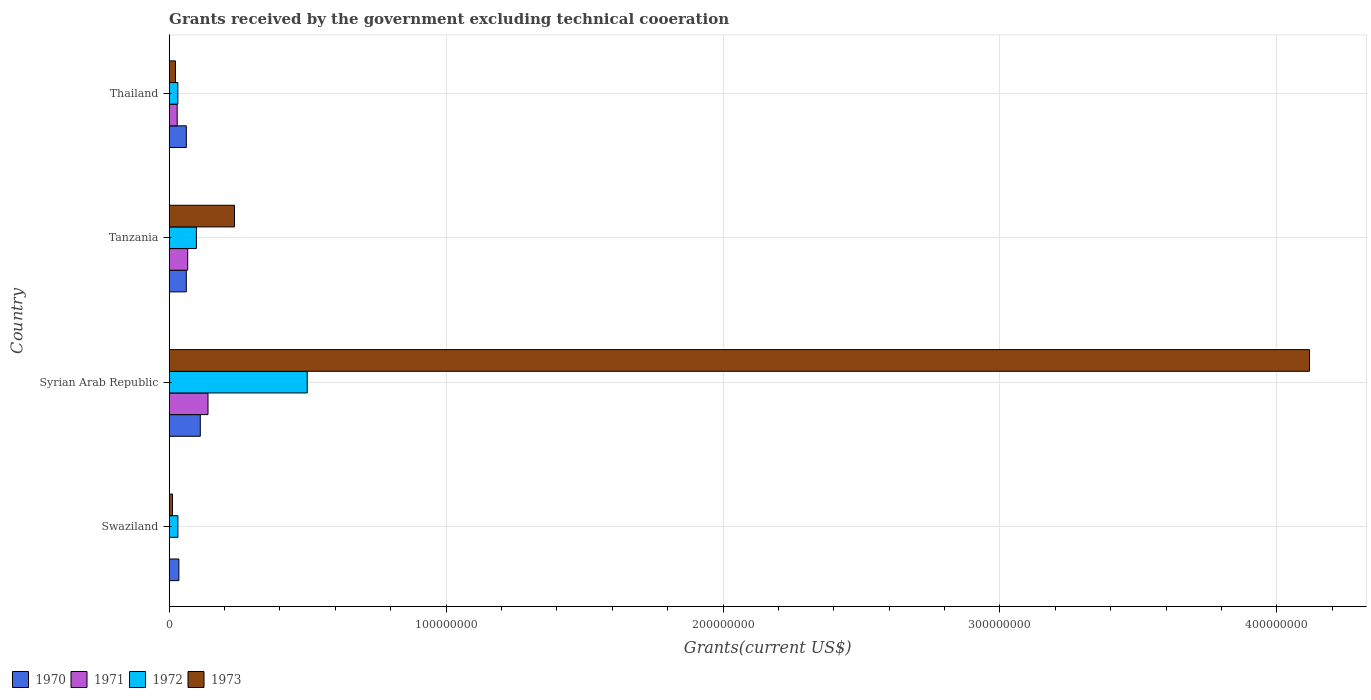How many groups of bars are there?
Ensure brevity in your answer.  4. Are the number of bars per tick equal to the number of legend labels?
Your answer should be compact. No. Are the number of bars on each tick of the Y-axis equal?
Offer a terse response. No. How many bars are there on the 2nd tick from the bottom?
Ensure brevity in your answer.  4. What is the label of the 3rd group of bars from the top?
Provide a succinct answer. Syrian Arab Republic. In how many cases, is the number of bars for a given country not equal to the number of legend labels?
Your response must be concise. 1. What is the total grants received by the government in 1971 in Syrian Arab Republic?
Offer a terse response. 1.40e+07. Across all countries, what is the maximum total grants received by the government in 1972?
Make the answer very short. 4.98e+07. Across all countries, what is the minimum total grants received by the government in 1970?
Ensure brevity in your answer.  3.49e+06. In which country was the total grants received by the government in 1972 maximum?
Keep it short and to the point. Syrian Arab Republic. What is the total total grants received by the government in 1970 in the graph?
Ensure brevity in your answer.  2.71e+07. What is the difference between the total grants received by the government in 1972 in Tanzania and that in Thailand?
Ensure brevity in your answer.  6.70e+06. What is the difference between the total grants received by the government in 1972 in Tanzania and the total grants received by the government in 1971 in Swaziland?
Ensure brevity in your answer.  9.82e+06. What is the average total grants received by the government in 1970 per country?
Provide a short and direct response. 6.77e+06. What is the difference between the total grants received by the government in 1972 and total grants received by the government in 1971 in Tanzania?
Offer a terse response. 3.14e+06. In how many countries, is the total grants received by the government in 1971 greater than 80000000 US$?
Your response must be concise. 0. What is the ratio of the total grants received by the government in 1972 in Swaziland to that in Syrian Arab Republic?
Your answer should be very brief. 0.06. What is the difference between the highest and the second highest total grants received by the government in 1970?
Your answer should be compact. 5.05e+06. What is the difference between the highest and the lowest total grants received by the government in 1972?
Provide a succinct answer. 4.67e+07. Is it the case that in every country, the sum of the total grants received by the government in 1973 and total grants received by the government in 1971 is greater than the total grants received by the government in 1972?
Give a very brief answer. No. What is the difference between two consecutive major ticks on the X-axis?
Offer a very short reply. 1.00e+08. Does the graph contain grids?
Your answer should be compact. Yes. How many legend labels are there?
Keep it short and to the point. 4. How are the legend labels stacked?
Make the answer very short. Horizontal. What is the title of the graph?
Your answer should be compact. Grants received by the government excluding technical cooeration. Does "2001" appear as one of the legend labels in the graph?
Offer a very short reply. No. What is the label or title of the X-axis?
Give a very brief answer. Grants(current US$). What is the Grants(current US$) in 1970 in Swaziland?
Your answer should be compact. 3.49e+06. What is the Grants(current US$) in 1971 in Swaziland?
Your response must be concise. 0. What is the Grants(current US$) of 1972 in Swaziland?
Offer a terse response. 3.14e+06. What is the Grants(current US$) of 1973 in Swaziland?
Your response must be concise. 1.18e+06. What is the Grants(current US$) in 1970 in Syrian Arab Republic?
Your answer should be very brief. 1.12e+07. What is the Grants(current US$) in 1971 in Syrian Arab Republic?
Your answer should be very brief. 1.40e+07. What is the Grants(current US$) in 1972 in Syrian Arab Republic?
Offer a very short reply. 4.98e+07. What is the Grants(current US$) of 1973 in Syrian Arab Republic?
Keep it short and to the point. 4.12e+08. What is the Grants(current US$) in 1970 in Tanzania?
Provide a short and direct response. 6.17e+06. What is the Grants(current US$) in 1971 in Tanzania?
Provide a succinct answer. 6.68e+06. What is the Grants(current US$) in 1972 in Tanzania?
Offer a terse response. 9.82e+06. What is the Grants(current US$) of 1973 in Tanzania?
Your answer should be very brief. 2.36e+07. What is the Grants(current US$) of 1970 in Thailand?
Your answer should be compact. 6.18e+06. What is the Grants(current US$) in 1971 in Thailand?
Provide a succinct answer. 2.88e+06. What is the Grants(current US$) of 1972 in Thailand?
Provide a succinct answer. 3.12e+06. What is the Grants(current US$) of 1973 in Thailand?
Your response must be concise. 2.27e+06. Across all countries, what is the maximum Grants(current US$) of 1970?
Keep it short and to the point. 1.12e+07. Across all countries, what is the maximum Grants(current US$) in 1971?
Provide a short and direct response. 1.40e+07. Across all countries, what is the maximum Grants(current US$) of 1972?
Make the answer very short. 4.98e+07. Across all countries, what is the maximum Grants(current US$) of 1973?
Your answer should be very brief. 4.12e+08. Across all countries, what is the minimum Grants(current US$) of 1970?
Offer a terse response. 3.49e+06. Across all countries, what is the minimum Grants(current US$) of 1972?
Your response must be concise. 3.12e+06. Across all countries, what is the minimum Grants(current US$) of 1973?
Give a very brief answer. 1.18e+06. What is the total Grants(current US$) of 1970 in the graph?
Provide a succinct answer. 2.71e+07. What is the total Grants(current US$) of 1971 in the graph?
Your response must be concise. 2.36e+07. What is the total Grants(current US$) of 1972 in the graph?
Keep it short and to the point. 6.59e+07. What is the total Grants(current US$) in 1973 in the graph?
Make the answer very short. 4.39e+08. What is the difference between the Grants(current US$) in 1970 in Swaziland and that in Syrian Arab Republic?
Make the answer very short. -7.74e+06. What is the difference between the Grants(current US$) of 1972 in Swaziland and that in Syrian Arab Republic?
Provide a short and direct response. -4.67e+07. What is the difference between the Grants(current US$) in 1973 in Swaziland and that in Syrian Arab Republic?
Offer a very short reply. -4.11e+08. What is the difference between the Grants(current US$) in 1970 in Swaziland and that in Tanzania?
Give a very brief answer. -2.68e+06. What is the difference between the Grants(current US$) in 1972 in Swaziland and that in Tanzania?
Your response must be concise. -6.68e+06. What is the difference between the Grants(current US$) in 1973 in Swaziland and that in Tanzania?
Give a very brief answer. -2.24e+07. What is the difference between the Grants(current US$) in 1970 in Swaziland and that in Thailand?
Make the answer very short. -2.69e+06. What is the difference between the Grants(current US$) in 1972 in Swaziland and that in Thailand?
Provide a short and direct response. 2.00e+04. What is the difference between the Grants(current US$) of 1973 in Swaziland and that in Thailand?
Offer a terse response. -1.09e+06. What is the difference between the Grants(current US$) in 1970 in Syrian Arab Republic and that in Tanzania?
Give a very brief answer. 5.06e+06. What is the difference between the Grants(current US$) in 1971 in Syrian Arab Republic and that in Tanzania?
Your response must be concise. 7.33e+06. What is the difference between the Grants(current US$) of 1972 in Syrian Arab Republic and that in Tanzania?
Offer a terse response. 4.00e+07. What is the difference between the Grants(current US$) of 1973 in Syrian Arab Republic and that in Tanzania?
Give a very brief answer. 3.88e+08. What is the difference between the Grants(current US$) of 1970 in Syrian Arab Republic and that in Thailand?
Make the answer very short. 5.05e+06. What is the difference between the Grants(current US$) in 1971 in Syrian Arab Republic and that in Thailand?
Offer a terse response. 1.11e+07. What is the difference between the Grants(current US$) of 1972 in Syrian Arab Republic and that in Thailand?
Your response must be concise. 4.67e+07. What is the difference between the Grants(current US$) in 1973 in Syrian Arab Republic and that in Thailand?
Provide a succinct answer. 4.10e+08. What is the difference between the Grants(current US$) of 1971 in Tanzania and that in Thailand?
Your response must be concise. 3.80e+06. What is the difference between the Grants(current US$) of 1972 in Tanzania and that in Thailand?
Ensure brevity in your answer.  6.70e+06. What is the difference between the Grants(current US$) of 1973 in Tanzania and that in Thailand?
Offer a very short reply. 2.13e+07. What is the difference between the Grants(current US$) of 1970 in Swaziland and the Grants(current US$) of 1971 in Syrian Arab Republic?
Provide a short and direct response. -1.05e+07. What is the difference between the Grants(current US$) in 1970 in Swaziland and the Grants(current US$) in 1972 in Syrian Arab Republic?
Give a very brief answer. -4.64e+07. What is the difference between the Grants(current US$) of 1970 in Swaziland and the Grants(current US$) of 1973 in Syrian Arab Republic?
Make the answer very short. -4.08e+08. What is the difference between the Grants(current US$) of 1972 in Swaziland and the Grants(current US$) of 1973 in Syrian Arab Republic?
Offer a very short reply. -4.09e+08. What is the difference between the Grants(current US$) of 1970 in Swaziland and the Grants(current US$) of 1971 in Tanzania?
Give a very brief answer. -3.19e+06. What is the difference between the Grants(current US$) of 1970 in Swaziland and the Grants(current US$) of 1972 in Tanzania?
Your answer should be compact. -6.33e+06. What is the difference between the Grants(current US$) in 1970 in Swaziland and the Grants(current US$) in 1973 in Tanzania?
Offer a very short reply. -2.01e+07. What is the difference between the Grants(current US$) in 1972 in Swaziland and the Grants(current US$) in 1973 in Tanzania?
Give a very brief answer. -2.04e+07. What is the difference between the Grants(current US$) in 1970 in Swaziland and the Grants(current US$) in 1971 in Thailand?
Your response must be concise. 6.10e+05. What is the difference between the Grants(current US$) in 1970 in Swaziland and the Grants(current US$) in 1972 in Thailand?
Ensure brevity in your answer.  3.70e+05. What is the difference between the Grants(current US$) of 1970 in Swaziland and the Grants(current US$) of 1973 in Thailand?
Offer a very short reply. 1.22e+06. What is the difference between the Grants(current US$) of 1972 in Swaziland and the Grants(current US$) of 1973 in Thailand?
Ensure brevity in your answer.  8.70e+05. What is the difference between the Grants(current US$) of 1970 in Syrian Arab Republic and the Grants(current US$) of 1971 in Tanzania?
Make the answer very short. 4.55e+06. What is the difference between the Grants(current US$) in 1970 in Syrian Arab Republic and the Grants(current US$) in 1972 in Tanzania?
Provide a short and direct response. 1.41e+06. What is the difference between the Grants(current US$) of 1970 in Syrian Arab Republic and the Grants(current US$) of 1973 in Tanzania?
Your answer should be compact. -1.24e+07. What is the difference between the Grants(current US$) in 1971 in Syrian Arab Republic and the Grants(current US$) in 1972 in Tanzania?
Provide a succinct answer. 4.19e+06. What is the difference between the Grants(current US$) of 1971 in Syrian Arab Republic and the Grants(current US$) of 1973 in Tanzania?
Ensure brevity in your answer.  -9.57e+06. What is the difference between the Grants(current US$) of 1972 in Syrian Arab Republic and the Grants(current US$) of 1973 in Tanzania?
Make the answer very short. 2.63e+07. What is the difference between the Grants(current US$) in 1970 in Syrian Arab Republic and the Grants(current US$) in 1971 in Thailand?
Your answer should be compact. 8.35e+06. What is the difference between the Grants(current US$) of 1970 in Syrian Arab Republic and the Grants(current US$) of 1972 in Thailand?
Offer a terse response. 8.11e+06. What is the difference between the Grants(current US$) in 1970 in Syrian Arab Republic and the Grants(current US$) in 1973 in Thailand?
Your answer should be very brief. 8.96e+06. What is the difference between the Grants(current US$) in 1971 in Syrian Arab Republic and the Grants(current US$) in 1972 in Thailand?
Your answer should be compact. 1.09e+07. What is the difference between the Grants(current US$) in 1971 in Syrian Arab Republic and the Grants(current US$) in 1973 in Thailand?
Make the answer very short. 1.17e+07. What is the difference between the Grants(current US$) in 1972 in Syrian Arab Republic and the Grants(current US$) in 1973 in Thailand?
Give a very brief answer. 4.76e+07. What is the difference between the Grants(current US$) of 1970 in Tanzania and the Grants(current US$) of 1971 in Thailand?
Your answer should be very brief. 3.29e+06. What is the difference between the Grants(current US$) of 1970 in Tanzania and the Grants(current US$) of 1972 in Thailand?
Give a very brief answer. 3.05e+06. What is the difference between the Grants(current US$) of 1970 in Tanzania and the Grants(current US$) of 1973 in Thailand?
Keep it short and to the point. 3.90e+06. What is the difference between the Grants(current US$) in 1971 in Tanzania and the Grants(current US$) in 1972 in Thailand?
Offer a very short reply. 3.56e+06. What is the difference between the Grants(current US$) of 1971 in Tanzania and the Grants(current US$) of 1973 in Thailand?
Your answer should be compact. 4.41e+06. What is the difference between the Grants(current US$) of 1972 in Tanzania and the Grants(current US$) of 1973 in Thailand?
Make the answer very short. 7.55e+06. What is the average Grants(current US$) of 1970 per country?
Offer a terse response. 6.77e+06. What is the average Grants(current US$) of 1971 per country?
Make the answer very short. 5.89e+06. What is the average Grants(current US$) of 1972 per country?
Provide a short and direct response. 1.65e+07. What is the average Grants(current US$) of 1973 per country?
Your response must be concise. 1.10e+08. What is the difference between the Grants(current US$) of 1970 and Grants(current US$) of 1972 in Swaziland?
Your answer should be very brief. 3.50e+05. What is the difference between the Grants(current US$) in 1970 and Grants(current US$) in 1973 in Swaziland?
Give a very brief answer. 2.31e+06. What is the difference between the Grants(current US$) of 1972 and Grants(current US$) of 1973 in Swaziland?
Your response must be concise. 1.96e+06. What is the difference between the Grants(current US$) in 1970 and Grants(current US$) in 1971 in Syrian Arab Republic?
Keep it short and to the point. -2.78e+06. What is the difference between the Grants(current US$) of 1970 and Grants(current US$) of 1972 in Syrian Arab Republic?
Keep it short and to the point. -3.86e+07. What is the difference between the Grants(current US$) of 1970 and Grants(current US$) of 1973 in Syrian Arab Republic?
Provide a succinct answer. -4.01e+08. What is the difference between the Grants(current US$) of 1971 and Grants(current US$) of 1972 in Syrian Arab Republic?
Provide a succinct answer. -3.58e+07. What is the difference between the Grants(current US$) of 1971 and Grants(current US$) of 1973 in Syrian Arab Republic?
Offer a terse response. -3.98e+08. What is the difference between the Grants(current US$) in 1972 and Grants(current US$) in 1973 in Syrian Arab Republic?
Make the answer very short. -3.62e+08. What is the difference between the Grants(current US$) of 1970 and Grants(current US$) of 1971 in Tanzania?
Your response must be concise. -5.10e+05. What is the difference between the Grants(current US$) in 1970 and Grants(current US$) in 1972 in Tanzania?
Ensure brevity in your answer.  -3.65e+06. What is the difference between the Grants(current US$) of 1970 and Grants(current US$) of 1973 in Tanzania?
Provide a short and direct response. -1.74e+07. What is the difference between the Grants(current US$) in 1971 and Grants(current US$) in 1972 in Tanzania?
Your answer should be very brief. -3.14e+06. What is the difference between the Grants(current US$) in 1971 and Grants(current US$) in 1973 in Tanzania?
Keep it short and to the point. -1.69e+07. What is the difference between the Grants(current US$) in 1972 and Grants(current US$) in 1973 in Tanzania?
Offer a terse response. -1.38e+07. What is the difference between the Grants(current US$) in 1970 and Grants(current US$) in 1971 in Thailand?
Your response must be concise. 3.30e+06. What is the difference between the Grants(current US$) of 1970 and Grants(current US$) of 1972 in Thailand?
Provide a short and direct response. 3.06e+06. What is the difference between the Grants(current US$) in 1970 and Grants(current US$) in 1973 in Thailand?
Offer a very short reply. 3.91e+06. What is the difference between the Grants(current US$) in 1971 and Grants(current US$) in 1972 in Thailand?
Offer a terse response. -2.40e+05. What is the difference between the Grants(current US$) in 1971 and Grants(current US$) in 1973 in Thailand?
Provide a short and direct response. 6.10e+05. What is the difference between the Grants(current US$) in 1972 and Grants(current US$) in 1973 in Thailand?
Your response must be concise. 8.50e+05. What is the ratio of the Grants(current US$) of 1970 in Swaziland to that in Syrian Arab Republic?
Provide a succinct answer. 0.31. What is the ratio of the Grants(current US$) of 1972 in Swaziland to that in Syrian Arab Republic?
Keep it short and to the point. 0.06. What is the ratio of the Grants(current US$) in 1973 in Swaziland to that in Syrian Arab Republic?
Make the answer very short. 0. What is the ratio of the Grants(current US$) in 1970 in Swaziland to that in Tanzania?
Offer a terse response. 0.57. What is the ratio of the Grants(current US$) of 1972 in Swaziland to that in Tanzania?
Your answer should be very brief. 0.32. What is the ratio of the Grants(current US$) of 1973 in Swaziland to that in Tanzania?
Your answer should be compact. 0.05. What is the ratio of the Grants(current US$) of 1970 in Swaziland to that in Thailand?
Provide a succinct answer. 0.56. What is the ratio of the Grants(current US$) in 1972 in Swaziland to that in Thailand?
Your answer should be very brief. 1.01. What is the ratio of the Grants(current US$) in 1973 in Swaziland to that in Thailand?
Ensure brevity in your answer.  0.52. What is the ratio of the Grants(current US$) of 1970 in Syrian Arab Republic to that in Tanzania?
Give a very brief answer. 1.82. What is the ratio of the Grants(current US$) in 1971 in Syrian Arab Republic to that in Tanzania?
Provide a short and direct response. 2.1. What is the ratio of the Grants(current US$) of 1972 in Syrian Arab Republic to that in Tanzania?
Your answer should be very brief. 5.08. What is the ratio of the Grants(current US$) in 1973 in Syrian Arab Republic to that in Tanzania?
Your answer should be very brief. 17.46. What is the ratio of the Grants(current US$) in 1970 in Syrian Arab Republic to that in Thailand?
Offer a terse response. 1.82. What is the ratio of the Grants(current US$) of 1971 in Syrian Arab Republic to that in Thailand?
Provide a succinct answer. 4.86. What is the ratio of the Grants(current US$) of 1972 in Syrian Arab Republic to that in Thailand?
Your response must be concise. 15.98. What is the ratio of the Grants(current US$) of 1973 in Syrian Arab Republic to that in Thailand?
Your answer should be compact. 181.41. What is the ratio of the Grants(current US$) in 1970 in Tanzania to that in Thailand?
Your answer should be very brief. 1. What is the ratio of the Grants(current US$) of 1971 in Tanzania to that in Thailand?
Provide a short and direct response. 2.32. What is the ratio of the Grants(current US$) in 1972 in Tanzania to that in Thailand?
Provide a short and direct response. 3.15. What is the ratio of the Grants(current US$) of 1973 in Tanzania to that in Thailand?
Ensure brevity in your answer.  10.39. What is the difference between the highest and the second highest Grants(current US$) in 1970?
Offer a very short reply. 5.05e+06. What is the difference between the highest and the second highest Grants(current US$) of 1971?
Provide a short and direct response. 7.33e+06. What is the difference between the highest and the second highest Grants(current US$) of 1972?
Provide a succinct answer. 4.00e+07. What is the difference between the highest and the second highest Grants(current US$) in 1973?
Provide a short and direct response. 3.88e+08. What is the difference between the highest and the lowest Grants(current US$) of 1970?
Offer a very short reply. 7.74e+06. What is the difference between the highest and the lowest Grants(current US$) in 1971?
Give a very brief answer. 1.40e+07. What is the difference between the highest and the lowest Grants(current US$) in 1972?
Ensure brevity in your answer.  4.67e+07. What is the difference between the highest and the lowest Grants(current US$) in 1973?
Keep it short and to the point. 4.11e+08. 